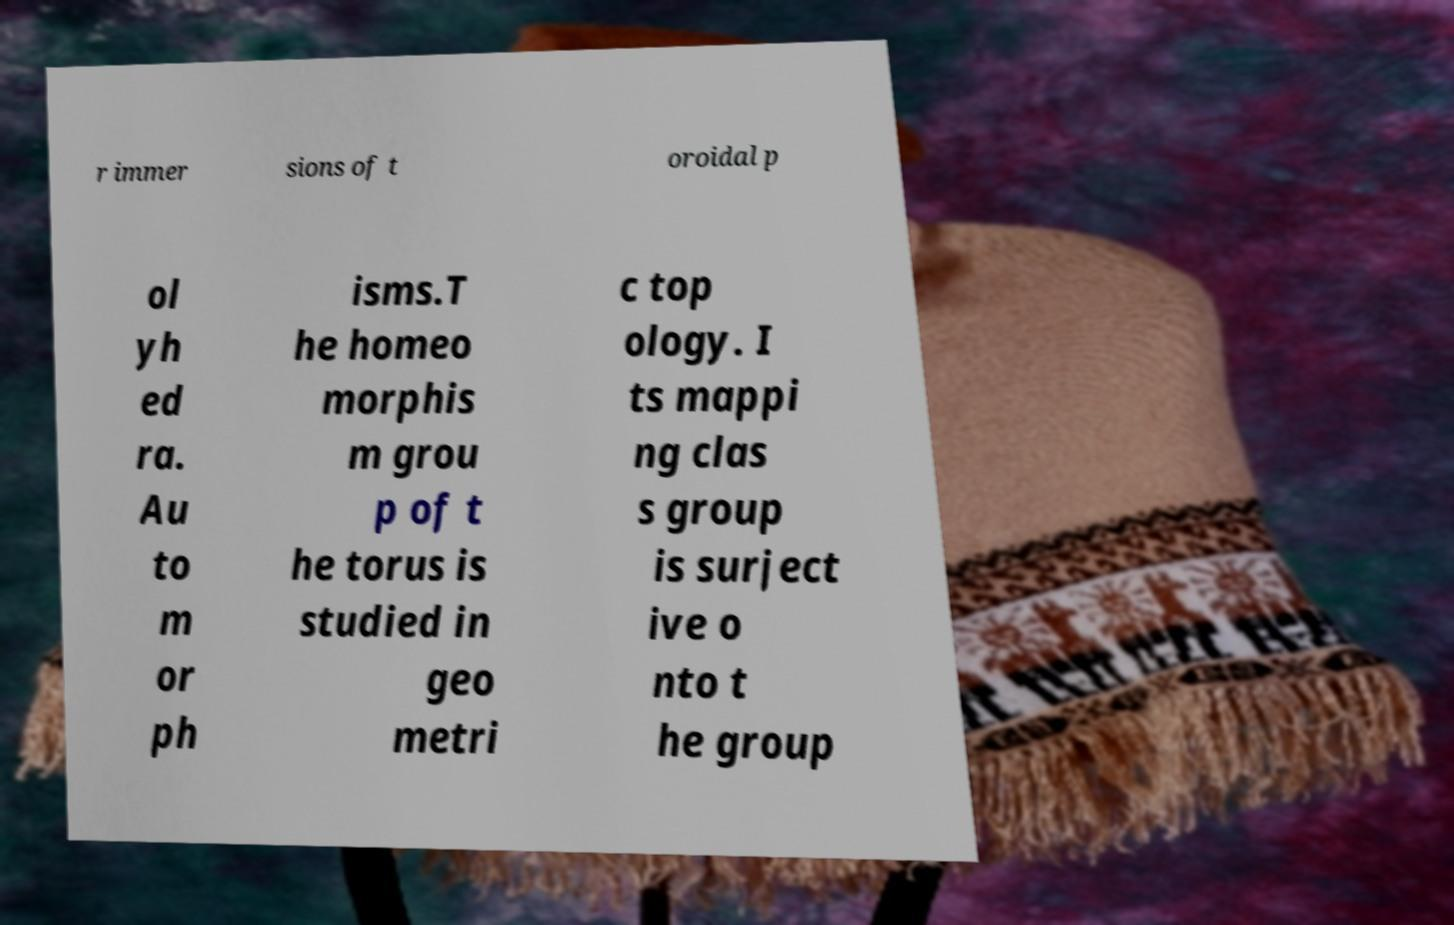For documentation purposes, I need the text within this image transcribed. Could you provide that? r immer sions of t oroidal p ol yh ed ra. Au to m or ph isms.T he homeo morphis m grou p of t he torus is studied in geo metri c top ology. I ts mappi ng clas s group is surject ive o nto t he group 